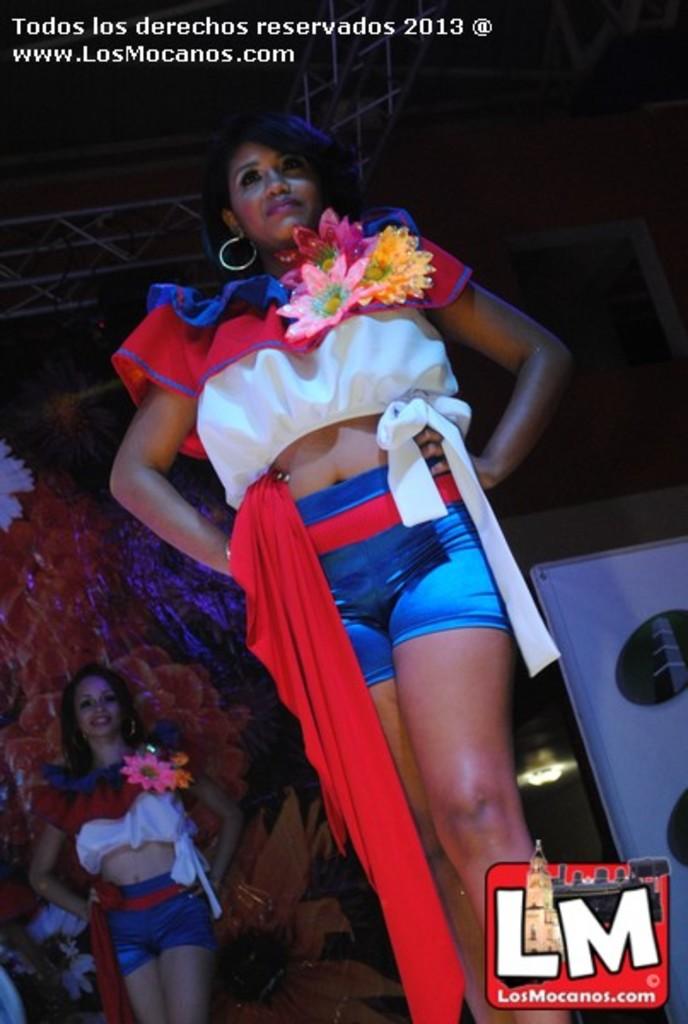What are the letters on the bottom?
Your answer should be compact. Lm. 